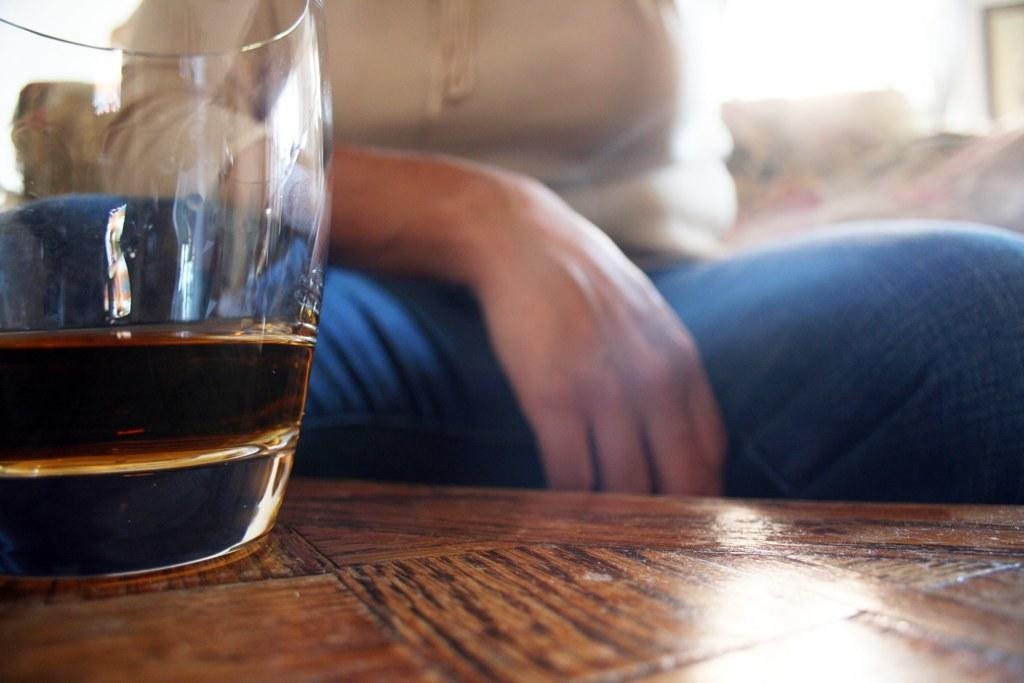What object is located on the left side of the image? There is a wine glass on the left side of the image. Where is the wine glass placed? The wine glass is placed on a table. Can you describe the person in the image? There is a person sitting behind the table in the image. What type of berry is being used as a coaster for the wine glass in the image? There is no berry present in the image, and the wine glass is not placed on a coaster. 